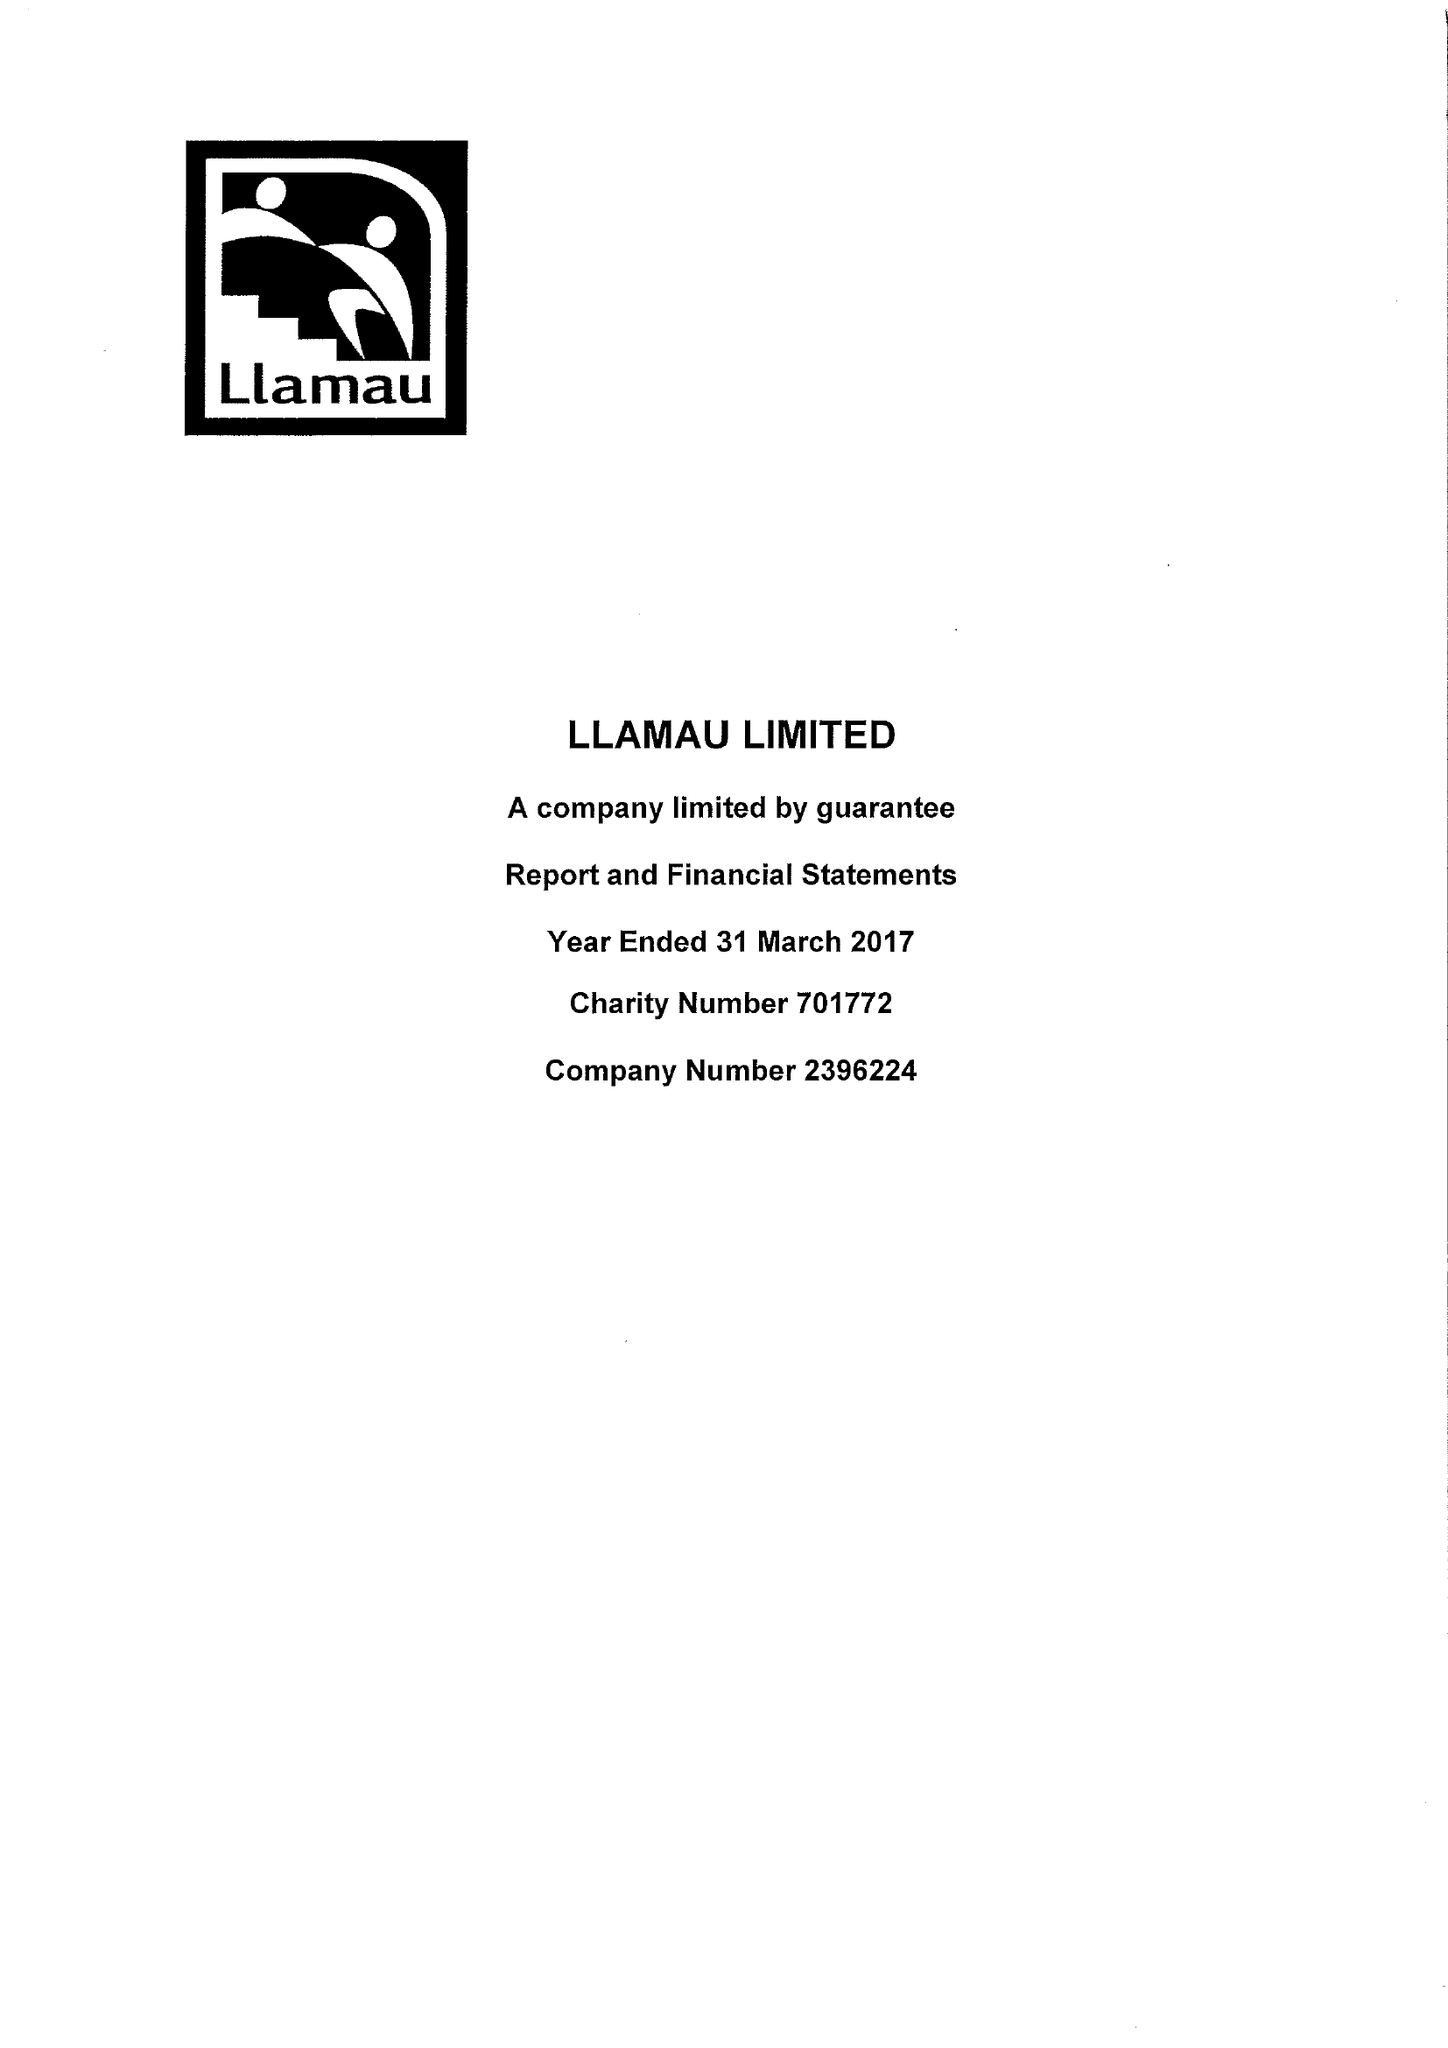What is the value for the address__post_town?
Answer the question using a single word or phrase. CARDIFF 